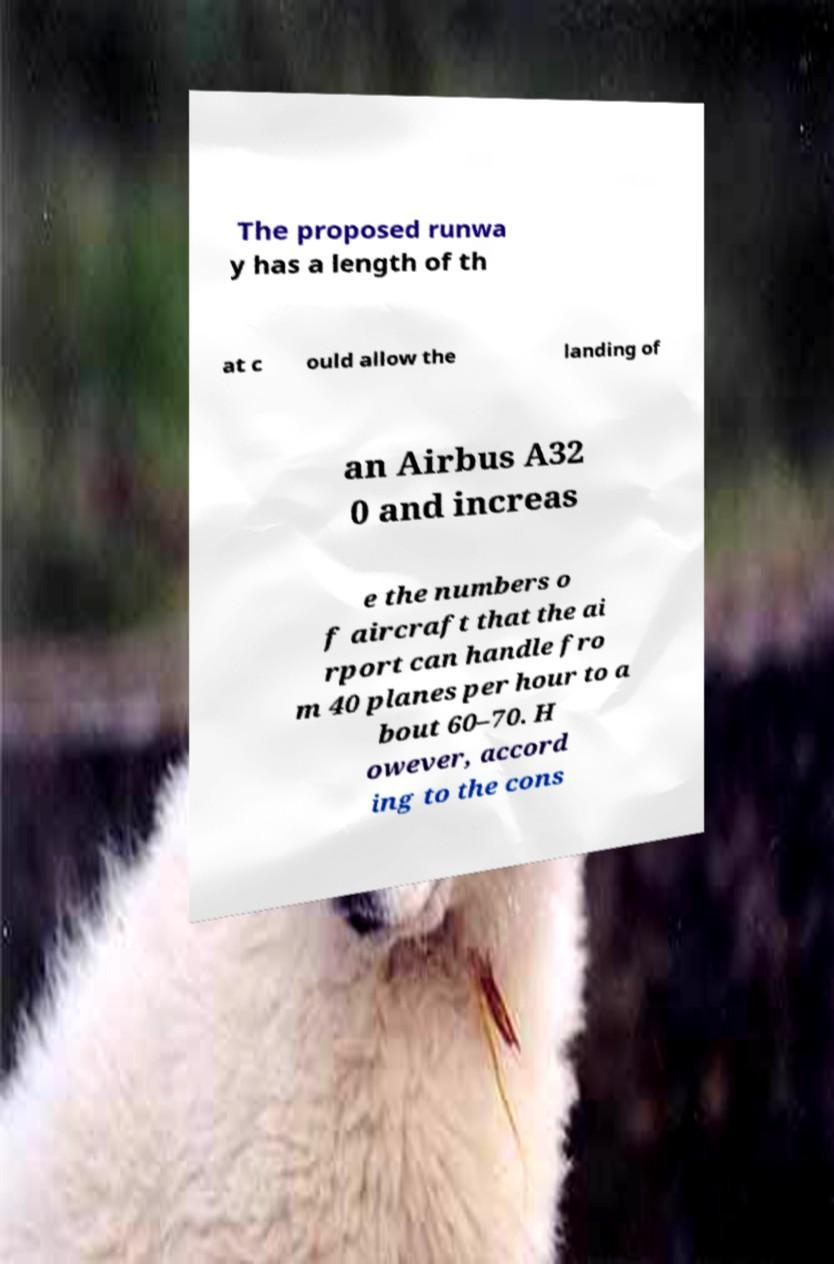Please identify and transcribe the text found in this image. The proposed runwa y has a length of th at c ould allow the landing of an Airbus A32 0 and increas e the numbers o f aircraft that the ai rport can handle fro m 40 planes per hour to a bout 60–70. H owever, accord ing to the cons 